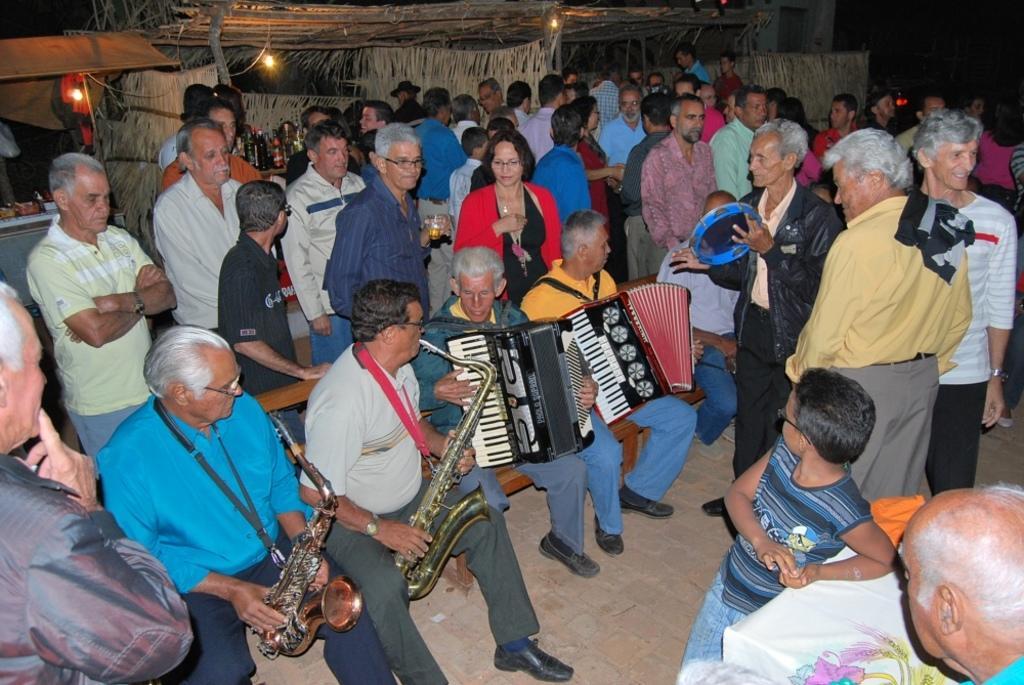How would you summarize this image in a sentence or two? In this image we can see four people are sitting on the bench. They are playing musical instrument. Right side of the image one man is standing and playing blue color musical instrument. Behind them so many people are standing and watching them. Background of the image one wooden shelter is present. Right bottom of the image one table is there, on which white cloth is present. 